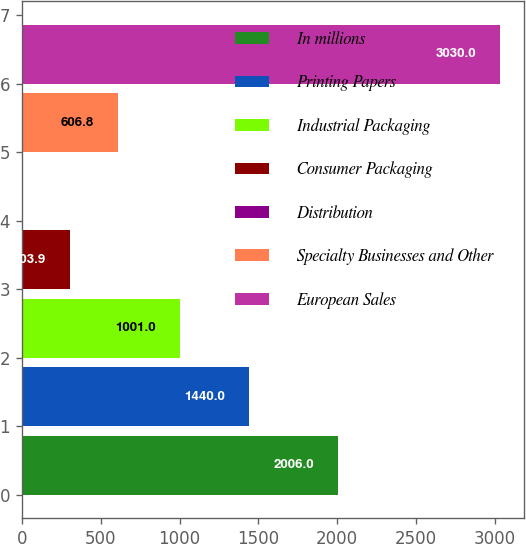<chart> <loc_0><loc_0><loc_500><loc_500><bar_chart><fcel>In millions<fcel>Printing Papers<fcel>Industrial Packaging<fcel>Consumer Packaging<fcel>Distribution<fcel>Specialty Businesses and Other<fcel>European Sales<nl><fcel>2006<fcel>1440<fcel>1001<fcel>303.9<fcel>1<fcel>606.8<fcel>3030<nl></chart> 